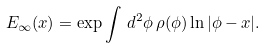<formula> <loc_0><loc_0><loc_500><loc_500>E _ { \infty } ( x ) = \exp \int \, d ^ { 2 } \phi \, \rho ( \phi ) \ln | \phi - x | .</formula> 